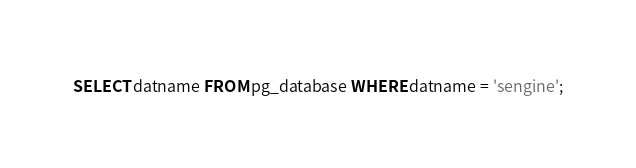<code> <loc_0><loc_0><loc_500><loc_500><_SQL_>SELECT datname FROM pg_database WHERE datname = 'sengine';
</code> 